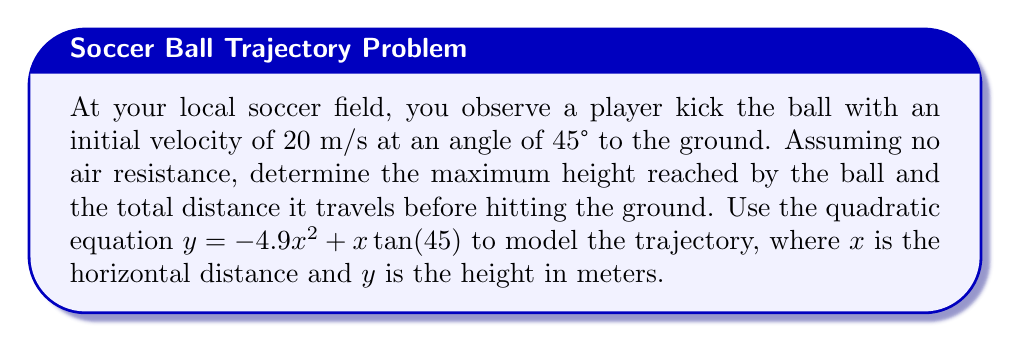Provide a solution to this math problem. Let's approach this step-by-step:

1) The trajectory equation is given as:
   $y = -4.9x^2 + x \tan(45°)$

2) We know that $\tan(45°) = 1$, so our equation simplifies to:
   $y = -4.9x^2 + x$

3) To find the maximum height, we need to find the vertex of this parabola. The x-coordinate of the vertex is given by $x = -\frac{b}{2a}$ where $a = -4.9$ and $b = 1$:

   $x = -\frac{1}{2(-4.9)} = \frac{1}{9.8} \approx 0.102$ meters

4) To find the y-coordinate (maximum height), we substitute this x-value back into our equation:

   $y = -4.9(0.102)^2 + 0.102 \approx 0.051$ meters

5) For the total distance, we need to find where the ball hits the ground, i.e., where $y = 0$:

   $0 = -4.9x^2 + x$
   $4.9x^2 = x$
   $x(4.9x - 1) = 0$

   Solving this, we get $x = 0$ or $x = \frac{1}{4.9} \approx 0.204$ meters

The non-zero solution, 0.204 meters, is the total horizontal distance traveled.
Answer: Maximum height: 0.051 m; Total distance: 0.204 m 